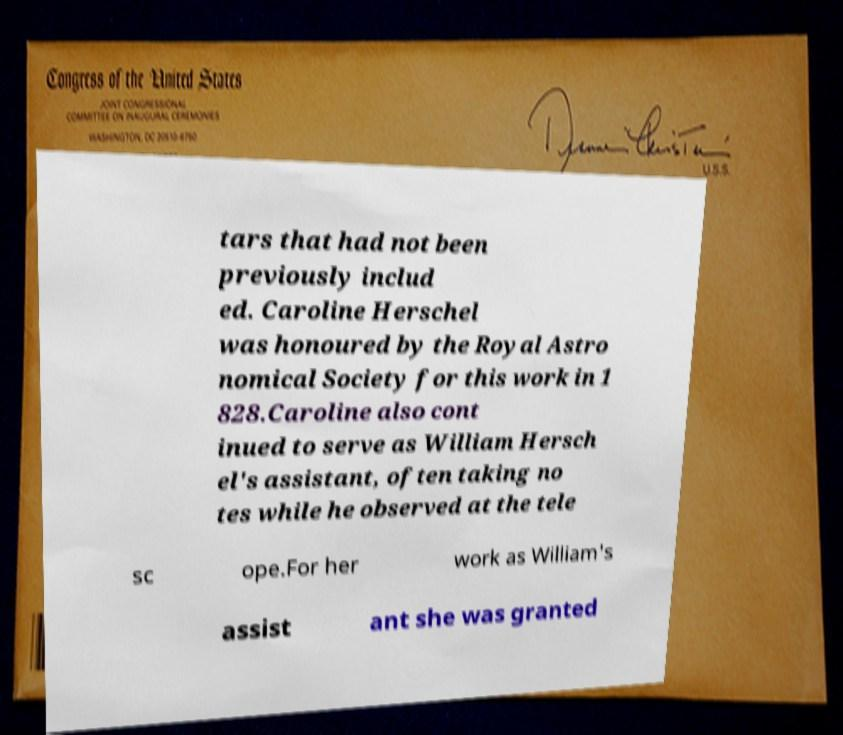Could you extract and type out the text from this image? tars that had not been previously includ ed. Caroline Herschel was honoured by the Royal Astro nomical Society for this work in 1 828.Caroline also cont inued to serve as William Hersch el's assistant, often taking no tes while he observed at the tele sc ope.For her work as William's assist ant she was granted 